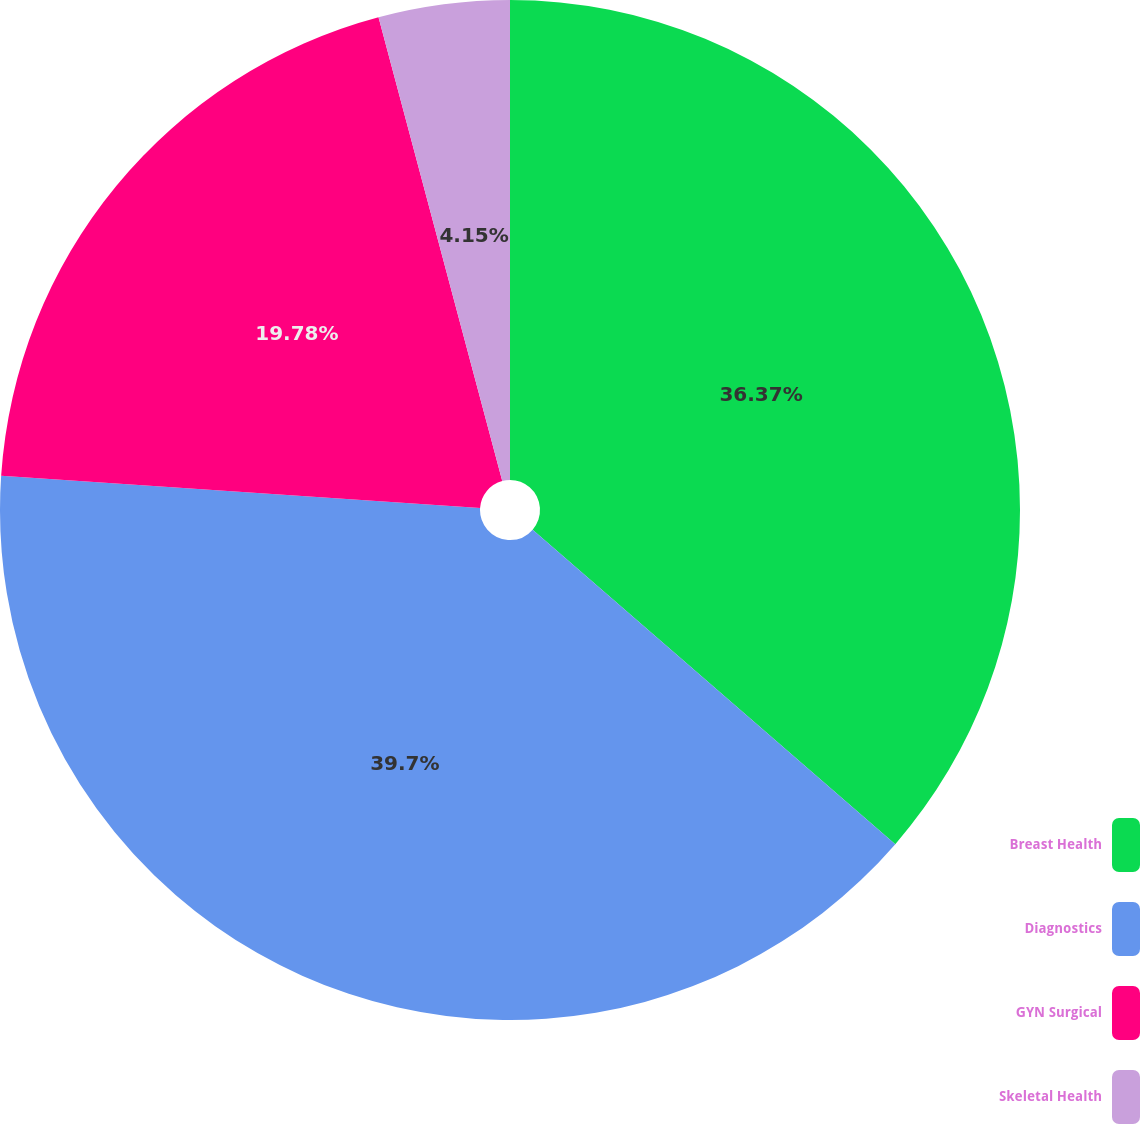<chart> <loc_0><loc_0><loc_500><loc_500><pie_chart><fcel>Breast Health<fcel>Diagnostics<fcel>GYN Surgical<fcel>Skeletal Health<nl><fcel>36.37%<fcel>39.7%<fcel>19.78%<fcel>4.15%<nl></chart> 